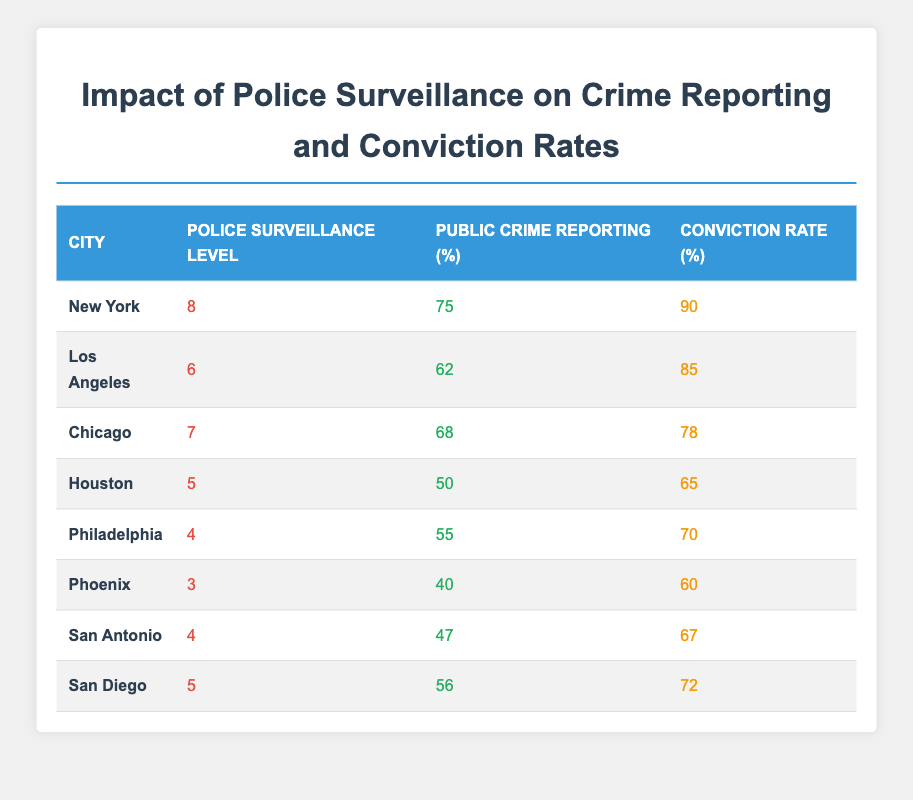What is the Police Surveillance Level for New York? The table lists New York with a Police Surveillance Level of 8.
Answer: 8 What is the Public Crime Reporting percentage in Houston? According to the table, Houston has a Public Crime Reporting percentage of 50.
Answer: 50 Which city has the highest Conviction Rate? The city with the highest Conviction Rate is New York with 90%.
Answer: New York Is the Police Surveillance Level directly proportional to the Public Crime Reporting in any city? Looking at the data, as police surveillance levels increase, public crime reporting percentages tend to increase as well, suggesting a potential direct proportionality. This trend can be observed from the data points of New York, Los Angeles, and Chicago.
Answer: Yes What is the difference in Conviction Rates between New York and Philadelphia? The Conviction Rate of New York is 90, and that of Philadelphia is 70. The difference is calculated as 90 - 70 = 20.
Answer: 20 What is the average Public Crime Reporting percentage of all the cities listed? First, add the Public Crime Reporting percentages of all cities: (75 + 62 + 68 + 50 + 55 + 40 + 47 + 56). This sum is 423, and there are 8 cities, so the average is 423 / 8 = 52.875.
Answer: 52.875 Which city has the lowest Police Surveillance Level? The table shows that Phoenix has the lowest Police Surveillance Level of 3.
Answer: Phoenix If we consider cities with a Police Surveillance Level of 5 or higher, what is the average Conviction Rate? The cities with Police Surveillance Levels of 5 or higher are New York (90), Los Angeles (85), Chicago (78), and San Diego (72). First, sum these Conviction Rates: 90 + 85 + 78 + 72 = 325. There are 4 cities, so average is 325 / 4 = 81.25.
Answer: 81.25 Is it true that more police surveillance leads to higher public crime reporting? Based on the data trends observed in cities such as New York and Chicago versus Phoenix, we can say yes, as higher surveillance levels correspond with higher reporting percentages.
Answer: Yes 